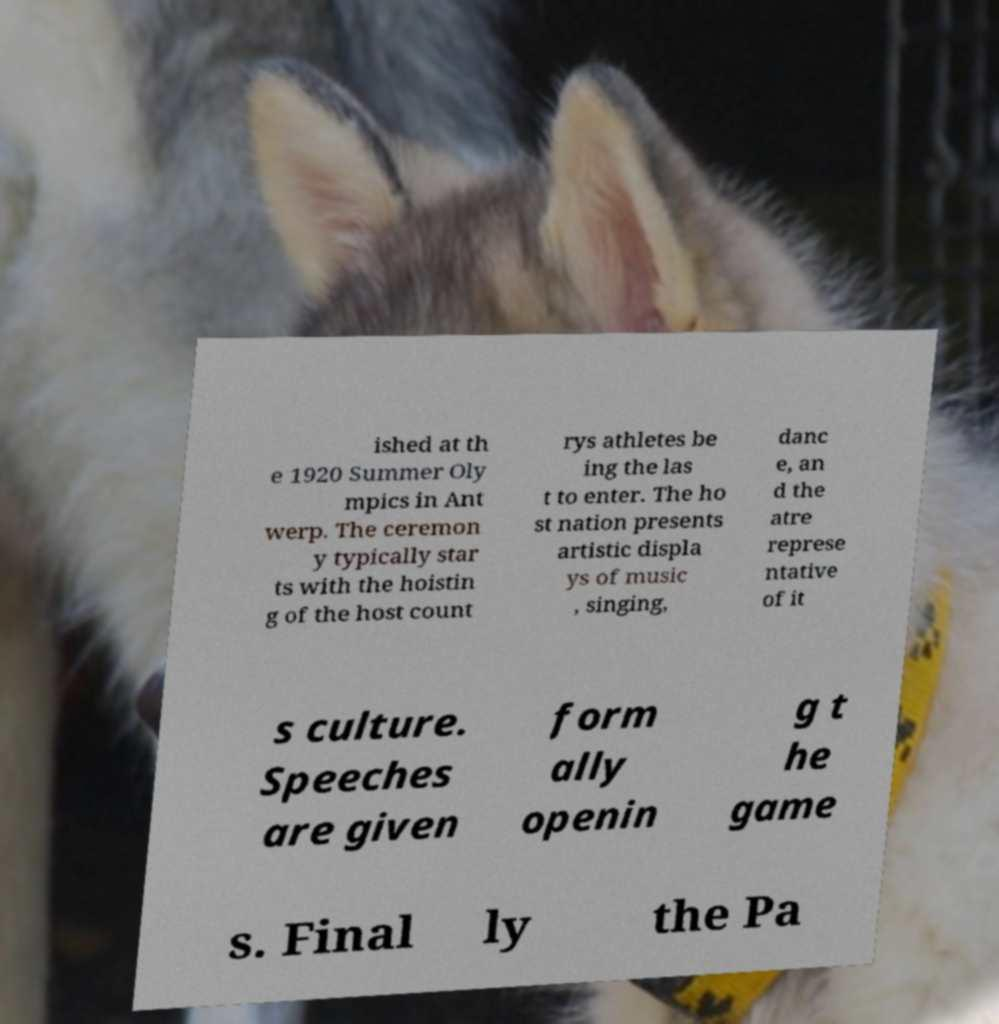Can you accurately transcribe the text from the provided image for me? ished at th e 1920 Summer Oly mpics in Ant werp. The ceremon y typically star ts with the hoistin g of the host count rys athletes be ing the las t to enter. The ho st nation presents artistic displa ys of music , singing, danc e, an d the atre represe ntative of it s culture. Speeches are given form ally openin g t he game s. Final ly the Pa 